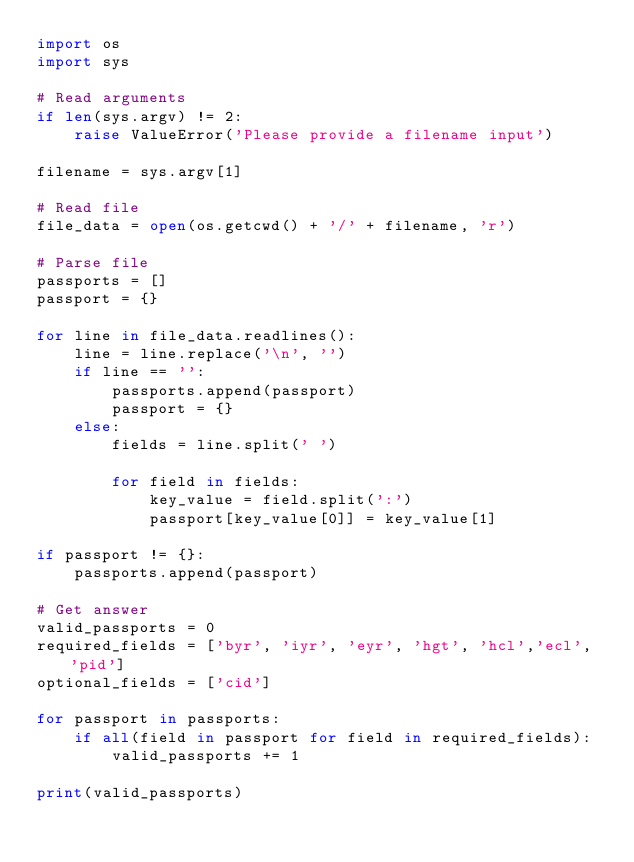Convert code to text. <code><loc_0><loc_0><loc_500><loc_500><_Python_>import os
import sys

# Read arguments
if len(sys.argv) != 2:
    raise ValueError('Please provide a filename input')

filename = sys.argv[1]

# Read file
file_data = open(os.getcwd() + '/' + filename, 'r')

# Parse file
passports = []
passport = {}

for line in file_data.readlines():
    line = line.replace('\n', '')
    if line == '':
        passports.append(passport)
        passport = {}
    else:
        fields = line.split(' ')

        for field in fields:
            key_value = field.split(':')
            passport[key_value[0]] = key_value[1]

if passport != {}:
    passports.append(passport)

# Get answer
valid_passports = 0
required_fields = ['byr', 'iyr', 'eyr', 'hgt', 'hcl','ecl', 'pid']
optional_fields = ['cid']

for passport in passports:
    if all(field in passport for field in required_fields):
        valid_passports += 1

print(valid_passports)
</code> 